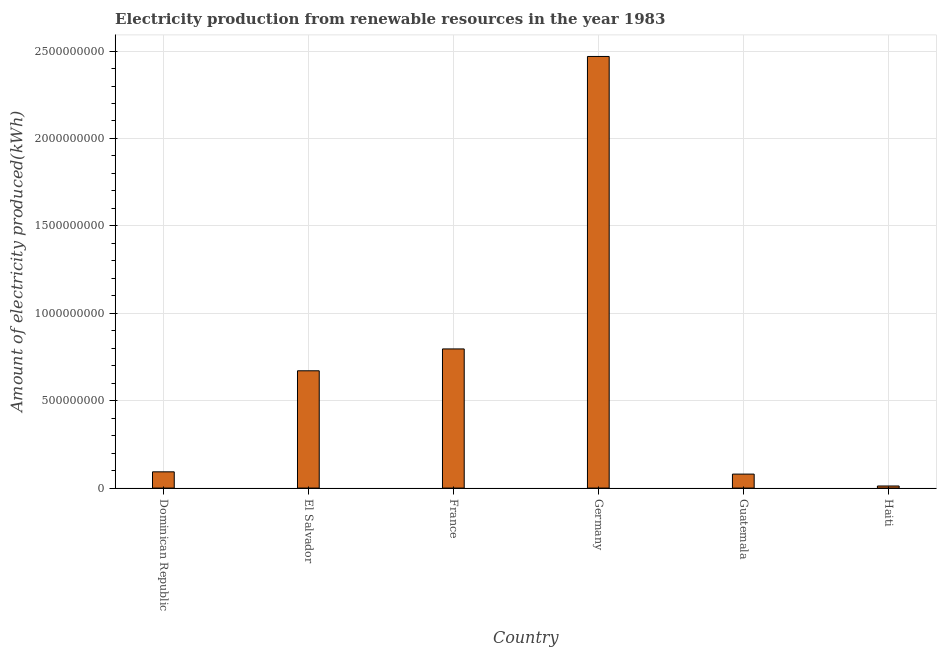Does the graph contain any zero values?
Ensure brevity in your answer.  No. What is the title of the graph?
Ensure brevity in your answer.  Electricity production from renewable resources in the year 1983. What is the label or title of the X-axis?
Your answer should be compact. Country. What is the label or title of the Y-axis?
Provide a short and direct response. Amount of electricity produced(kWh). What is the amount of electricity produced in Germany?
Ensure brevity in your answer.  2.47e+09. Across all countries, what is the maximum amount of electricity produced?
Keep it short and to the point. 2.47e+09. In which country was the amount of electricity produced minimum?
Your response must be concise. Haiti. What is the sum of the amount of electricity produced?
Provide a short and direct response. 4.12e+09. What is the difference between the amount of electricity produced in El Salvador and Germany?
Offer a terse response. -1.80e+09. What is the average amount of electricity produced per country?
Offer a very short reply. 6.87e+08. What is the median amount of electricity produced?
Your answer should be compact. 3.82e+08. What is the ratio of the amount of electricity produced in Germany to that in Guatemala?
Your answer should be very brief. 30.86. Is the amount of electricity produced in Dominican Republic less than that in El Salvador?
Provide a succinct answer. Yes. What is the difference between the highest and the second highest amount of electricity produced?
Your answer should be compact. 1.67e+09. What is the difference between the highest and the lowest amount of electricity produced?
Your answer should be very brief. 2.46e+09. How many countries are there in the graph?
Ensure brevity in your answer.  6. Are the values on the major ticks of Y-axis written in scientific E-notation?
Offer a very short reply. No. What is the Amount of electricity produced(kWh) in Dominican Republic?
Your answer should be compact. 9.30e+07. What is the Amount of electricity produced(kWh) of El Salvador?
Give a very brief answer. 6.71e+08. What is the Amount of electricity produced(kWh) in France?
Offer a terse response. 7.96e+08. What is the Amount of electricity produced(kWh) of Germany?
Provide a short and direct response. 2.47e+09. What is the Amount of electricity produced(kWh) of Guatemala?
Provide a short and direct response. 8.00e+07. What is the difference between the Amount of electricity produced(kWh) in Dominican Republic and El Salvador?
Provide a succinct answer. -5.78e+08. What is the difference between the Amount of electricity produced(kWh) in Dominican Republic and France?
Your response must be concise. -7.03e+08. What is the difference between the Amount of electricity produced(kWh) in Dominican Republic and Germany?
Make the answer very short. -2.38e+09. What is the difference between the Amount of electricity produced(kWh) in Dominican Republic and Guatemala?
Provide a succinct answer. 1.30e+07. What is the difference between the Amount of electricity produced(kWh) in Dominican Republic and Haiti?
Ensure brevity in your answer.  8.10e+07. What is the difference between the Amount of electricity produced(kWh) in El Salvador and France?
Your answer should be compact. -1.25e+08. What is the difference between the Amount of electricity produced(kWh) in El Salvador and Germany?
Provide a short and direct response. -1.80e+09. What is the difference between the Amount of electricity produced(kWh) in El Salvador and Guatemala?
Ensure brevity in your answer.  5.91e+08. What is the difference between the Amount of electricity produced(kWh) in El Salvador and Haiti?
Provide a succinct answer. 6.59e+08. What is the difference between the Amount of electricity produced(kWh) in France and Germany?
Ensure brevity in your answer.  -1.67e+09. What is the difference between the Amount of electricity produced(kWh) in France and Guatemala?
Ensure brevity in your answer.  7.16e+08. What is the difference between the Amount of electricity produced(kWh) in France and Haiti?
Offer a terse response. 7.84e+08. What is the difference between the Amount of electricity produced(kWh) in Germany and Guatemala?
Keep it short and to the point. 2.39e+09. What is the difference between the Amount of electricity produced(kWh) in Germany and Haiti?
Offer a terse response. 2.46e+09. What is the difference between the Amount of electricity produced(kWh) in Guatemala and Haiti?
Make the answer very short. 6.80e+07. What is the ratio of the Amount of electricity produced(kWh) in Dominican Republic to that in El Salvador?
Provide a short and direct response. 0.14. What is the ratio of the Amount of electricity produced(kWh) in Dominican Republic to that in France?
Provide a succinct answer. 0.12. What is the ratio of the Amount of electricity produced(kWh) in Dominican Republic to that in Germany?
Provide a short and direct response. 0.04. What is the ratio of the Amount of electricity produced(kWh) in Dominican Republic to that in Guatemala?
Provide a succinct answer. 1.16. What is the ratio of the Amount of electricity produced(kWh) in Dominican Republic to that in Haiti?
Provide a succinct answer. 7.75. What is the ratio of the Amount of electricity produced(kWh) in El Salvador to that in France?
Your answer should be compact. 0.84. What is the ratio of the Amount of electricity produced(kWh) in El Salvador to that in Germany?
Provide a succinct answer. 0.27. What is the ratio of the Amount of electricity produced(kWh) in El Salvador to that in Guatemala?
Your answer should be compact. 8.39. What is the ratio of the Amount of electricity produced(kWh) in El Salvador to that in Haiti?
Your answer should be very brief. 55.92. What is the ratio of the Amount of electricity produced(kWh) in France to that in Germany?
Your answer should be compact. 0.32. What is the ratio of the Amount of electricity produced(kWh) in France to that in Guatemala?
Your answer should be compact. 9.95. What is the ratio of the Amount of electricity produced(kWh) in France to that in Haiti?
Your response must be concise. 66.33. What is the ratio of the Amount of electricity produced(kWh) in Germany to that in Guatemala?
Give a very brief answer. 30.86. What is the ratio of the Amount of electricity produced(kWh) in Germany to that in Haiti?
Provide a succinct answer. 205.75. What is the ratio of the Amount of electricity produced(kWh) in Guatemala to that in Haiti?
Provide a short and direct response. 6.67. 